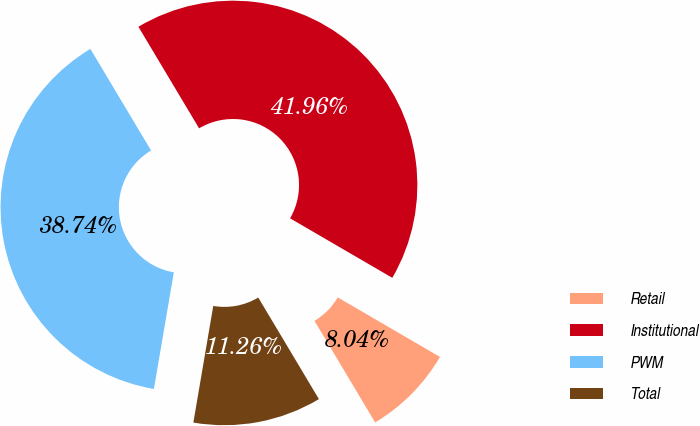<chart> <loc_0><loc_0><loc_500><loc_500><pie_chart><fcel>Retail<fcel>Institutional<fcel>PWM<fcel>Total<nl><fcel>8.04%<fcel>41.96%<fcel>38.74%<fcel>11.26%<nl></chart> 